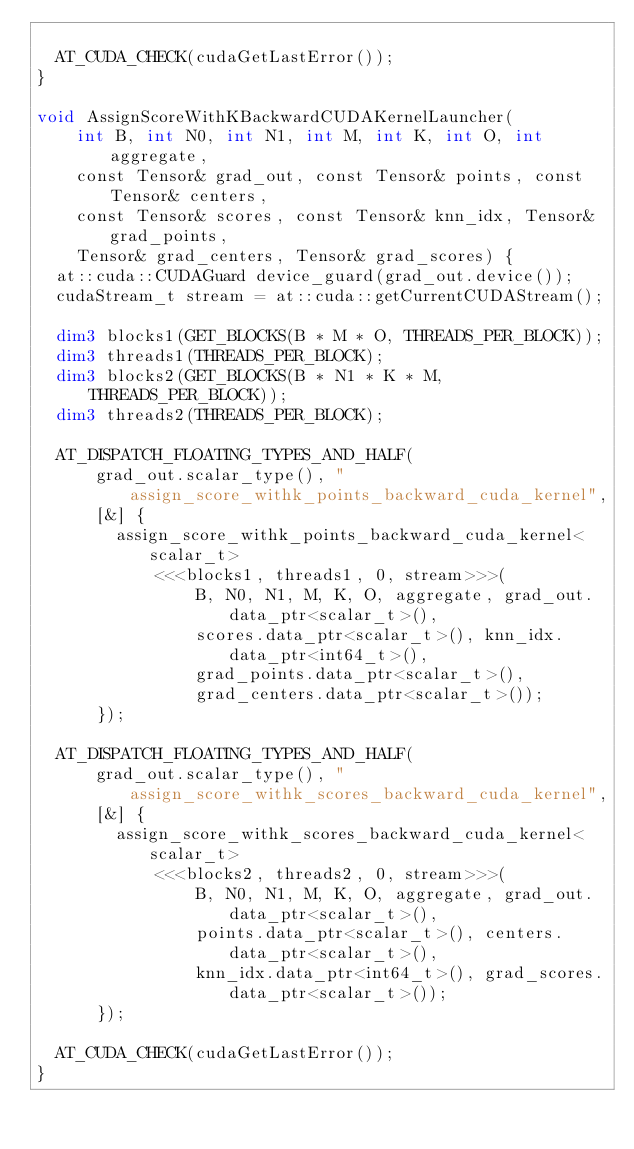<code> <loc_0><loc_0><loc_500><loc_500><_Cuda_>
  AT_CUDA_CHECK(cudaGetLastError());
}

void AssignScoreWithKBackwardCUDAKernelLauncher(
    int B, int N0, int N1, int M, int K, int O, int aggregate,
    const Tensor& grad_out, const Tensor& points, const Tensor& centers,
    const Tensor& scores, const Tensor& knn_idx, Tensor& grad_points,
    Tensor& grad_centers, Tensor& grad_scores) {
  at::cuda::CUDAGuard device_guard(grad_out.device());
  cudaStream_t stream = at::cuda::getCurrentCUDAStream();

  dim3 blocks1(GET_BLOCKS(B * M * O, THREADS_PER_BLOCK));
  dim3 threads1(THREADS_PER_BLOCK);
  dim3 blocks2(GET_BLOCKS(B * N1 * K * M, THREADS_PER_BLOCK));
  dim3 threads2(THREADS_PER_BLOCK);

  AT_DISPATCH_FLOATING_TYPES_AND_HALF(
      grad_out.scalar_type(), "assign_score_withk_points_backward_cuda_kernel",
      [&] {
        assign_score_withk_points_backward_cuda_kernel<scalar_t>
            <<<blocks1, threads1, 0, stream>>>(
                B, N0, N1, M, K, O, aggregate, grad_out.data_ptr<scalar_t>(),
                scores.data_ptr<scalar_t>(), knn_idx.data_ptr<int64_t>(),
                grad_points.data_ptr<scalar_t>(),
                grad_centers.data_ptr<scalar_t>());
      });

  AT_DISPATCH_FLOATING_TYPES_AND_HALF(
      grad_out.scalar_type(), "assign_score_withk_scores_backward_cuda_kernel",
      [&] {
        assign_score_withk_scores_backward_cuda_kernel<scalar_t>
            <<<blocks2, threads2, 0, stream>>>(
                B, N0, N1, M, K, O, aggregate, grad_out.data_ptr<scalar_t>(),
                points.data_ptr<scalar_t>(), centers.data_ptr<scalar_t>(),
                knn_idx.data_ptr<int64_t>(), grad_scores.data_ptr<scalar_t>());
      });

  AT_CUDA_CHECK(cudaGetLastError());
}
</code> 